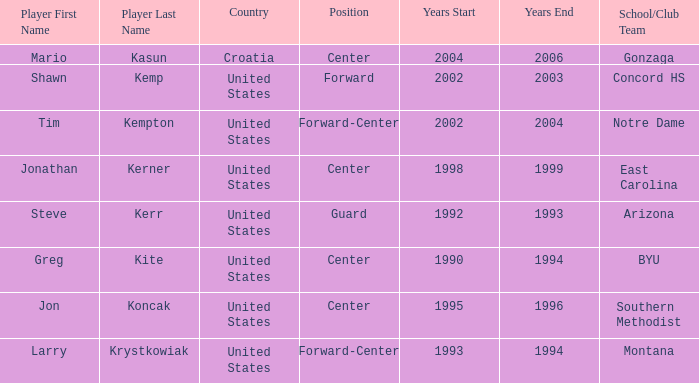What years in Orlando have the United States as the nationality, with concord hs as the school/club team? 2002–2003. 